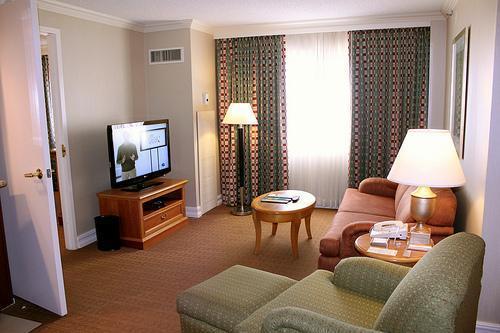How many TVs are there?
Give a very brief answer. 1. 